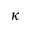<formula> <loc_0><loc_0><loc_500><loc_500>\kappa</formula> 